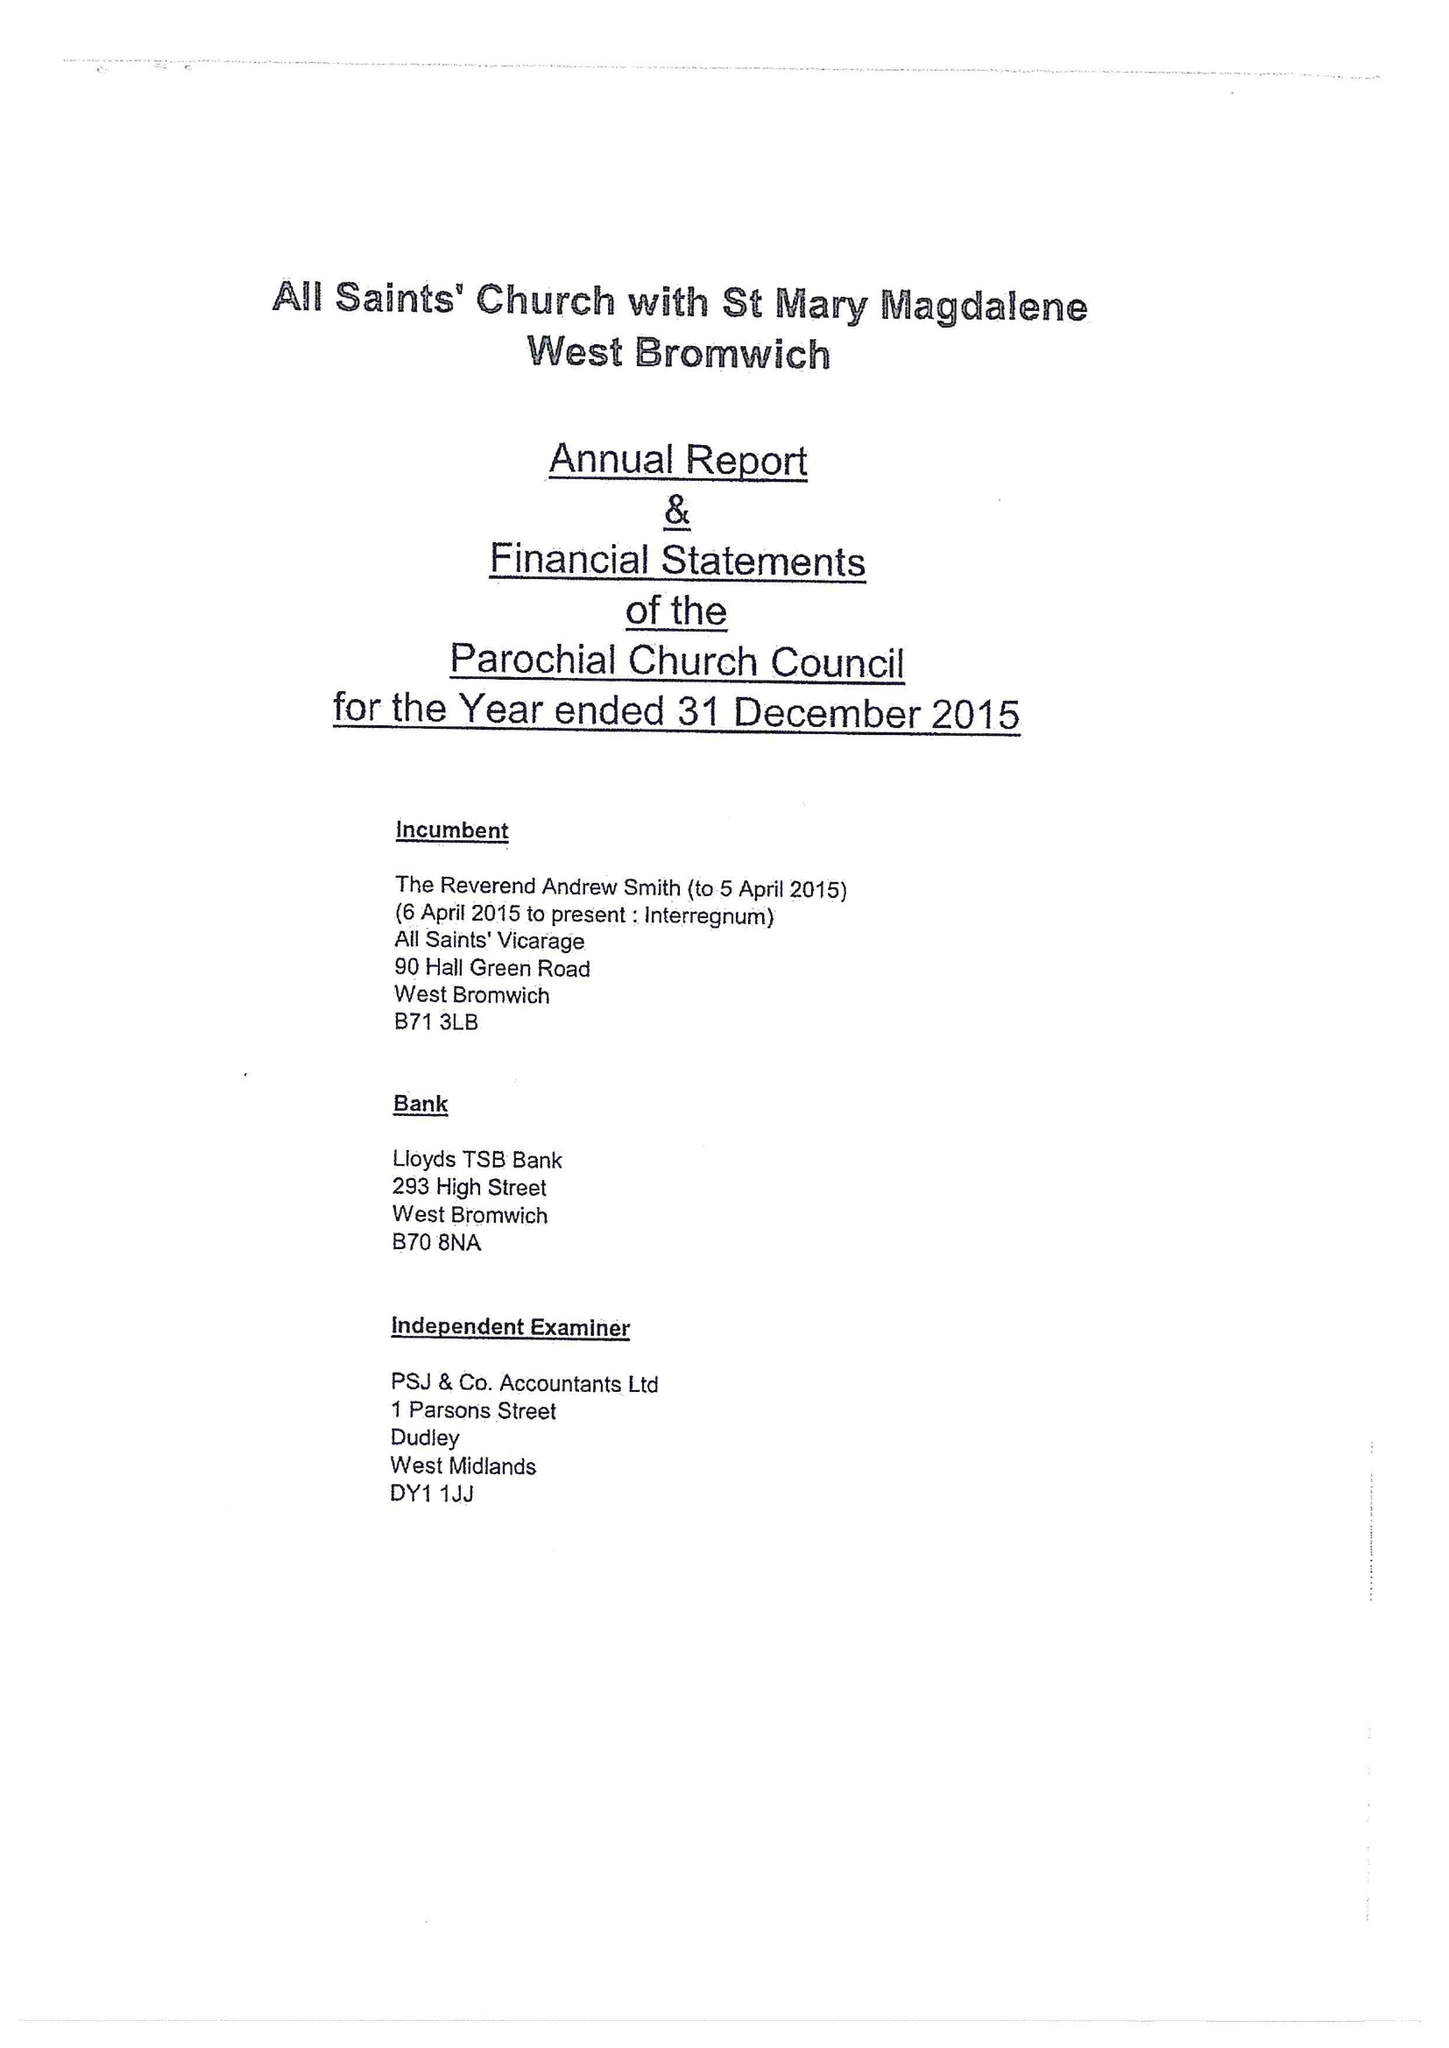What is the value for the report_date?
Answer the question using a single word or phrase. 2015-12-31 